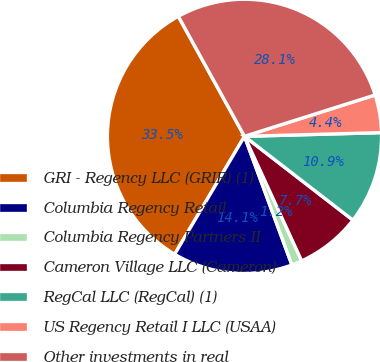<chart> <loc_0><loc_0><loc_500><loc_500><pie_chart><fcel>GRI - Regency LLC (GRIR) (1)<fcel>Columbia Regency Retail<fcel>Columbia Regency Partners II<fcel>Cameron Village LLC (Cameron)<fcel>RegCal LLC (RegCal) (1)<fcel>US Regency Retail I LLC (USAA)<fcel>Other investments in real<nl><fcel>33.47%<fcel>14.13%<fcel>1.23%<fcel>7.68%<fcel>10.9%<fcel>4.45%<fcel>28.14%<nl></chart> 